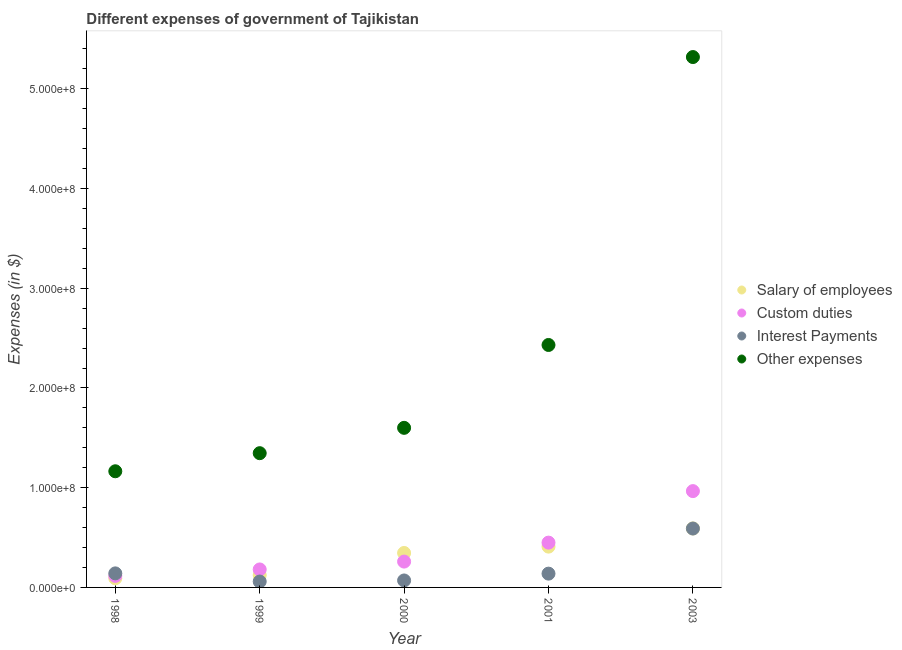Is the number of dotlines equal to the number of legend labels?
Your answer should be very brief. Yes. What is the amount spent on interest payments in 2001?
Keep it short and to the point. 1.38e+07. Across all years, what is the maximum amount spent on salary of employees?
Provide a succinct answer. 5.91e+07. Across all years, what is the minimum amount spent on interest payments?
Offer a very short reply. 5.92e+06. In which year was the amount spent on other expenses maximum?
Give a very brief answer. 2003. In which year was the amount spent on other expenses minimum?
Ensure brevity in your answer.  1998. What is the total amount spent on salary of employees in the graph?
Your response must be concise. 1.56e+08. What is the difference between the amount spent on other expenses in 1999 and that in 2001?
Provide a short and direct response. -1.08e+08. What is the difference between the amount spent on interest payments in 2000 and the amount spent on custom duties in 1998?
Keep it short and to the point. -4.60e+06. What is the average amount spent on custom duties per year?
Your response must be concise. 3.94e+07. In the year 2000, what is the difference between the amount spent on custom duties and amount spent on other expenses?
Ensure brevity in your answer.  -1.34e+08. What is the ratio of the amount spent on salary of employees in 1998 to that in 2001?
Your answer should be very brief. 0.22. Is the amount spent on salary of employees in 2000 less than that in 2001?
Your response must be concise. Yes. What is the difference between the highest and the second highest amount spent on salary of employees?
Offer a terse response. 1.82e+07. What is the difference between the highest and the lowest amount spent on interest payments?
Provide a succinct answer. 5.31e+07. In how many years, is the amount spent on salary of employees greater than the average amount spent on salary of employees taken over all years?
Keep it short and to the point. 3. Is it the case that in every year, the sum of the amount spent on custom duties and amount spent on other expenses is greater than the sum of amount spent on salary of employees and amount spent on interest payments?
Your response must be concise. No. Is it the case that in every year, the sum of the amount spent on salary of employees and amount spent on custom duties is greater than the amount spent on interest payments?
Provide a short and direct response. Yes. Does the amount spent on interest payments monotonically increase over the years?
Give a very brief answer. No. Is the amount spent on custom duties strictly greater than the amount spent on interest payments over the years?
Offer a very short reply. No. Is the amount spent on salary of employees strictly less than the amount spent on other expenses over the years?
Provide a short and direct response. Yes. How many dotlines are there?
Provide a succinct answer. 4. How many years are there in the graph?
Your answer should be compact. 5. What is the difference between two consecutive major ticks on the Y-axis?
Your answer should be compact. 1.00e+08. Are the values on the major ticks of Y-axis written in scientific E-notation?
Provide a succinct answer. Yes. Does the graph contain any zero values?
Keep it short and to the point. No. Does the graph contain grids?
Ensure brevity in your answer.  No. How many legend labels are there?
Offer a terse response. 4. How are the legend labels stacked?
Your answer should be very brief. Vertical. What is the title of the graph?
Provide a succinct answer. Different expenses of government of Tajikistan. Does "Periodicity assessment" appear as one of the legend labels in the graph?
Offer a very short reply. No. What is the label or title of the Y-axis?
Provide a succinct answer. Expenses (in $). What is the Expenses (in $) in Salary of employees in 1998?
Provide a short and direct response. 9.12e+06. What is the Expenses (in $) in Custom duties in 1998?
Give a very brief answer. 1.16e+07. What is the Expenses (in $) in Interest Payments in 1998?
Your answer should be compact. 1.41e+07. What is the Expenses (in $) of Other expenses in 1998?
Provide a short and direct response. 1.16e+08. What is the Expenses (in $) of Salary of employees in 1999?
Offer a terse response. 1.22e+07. What is the Expenses (in $) of Custom duties in 1999?
Provide a succinct answer. 1.80e+07. What is the Expenses (in $) in Interest Payments in 1999?
Your response must be concise. 5.92e+06. What is the Expenses (in $) of Other expenses in 1999?
Offer a terse response. 1.35e+08. What is the Expenses (in $) of Salary of employees in 2000?
Give a very brief answer. 3.45e+07. What is the Expenses (in $) in Custom duties in 2000?
Ensure brevity in your answer.  2.59e+07. What is the Expenses (in $) in Interest Payments in 2000?
Make the answer very short. 6.98e+06. What is the Expenses (in $) of Other expenses in 2000?
Make the answer very short. 1.60e+08. What is the Expenses (in $) of Salary of employees in 2001?
Offer a very short reply. 4.09e+07. What is the Expenses (in $) in Custom duties in 2001?
Provide a succinct answer. 4.49e+07. What is the Expenses (in $) in Interest Payments in 2001?
Ensure brevity in your answer.  1.38e+07. What is the Expenses (in $) in Other expenses in 2001?
Offer a terse response. 2.43e+08. What is the Expenses (in $) in Salary of employees in 2003?
Give a very brief answer. 5.91e+07. What is the Expenses (in $) in Custom duties in 2003?
Your answer should be compact. 9.66e+07. What is the Expenses (in $) in Interest Payments in 2003?
Provide a succinct answer. 5.90e+07. What is the Expenses (in $) in Other expenses in 2003?
Your response must be concise. 5.32e+08. Across all years, what is the maximum Expenses (in $) of Salary of employees?
Provide a succinct answer. 5.91e+07. Across all years, what is the maximum Expenses (in $) of Custom duties?
Your answer should be very brief. 9.66e+07. Across all years, what is the maximum Expenses (in $) of Interest Payments?
Ensure brevity in your answer.  5.90e+07. Across all years, what is the maximum Expenses (in $) in Other expenses?
Offer a terse response. 5.32e+08. Across all years, what is the minimum Expenses (in $) in Salary of employees?
Offer a terse response. 9.12e+06. Across all years, what is the minimum Expenses (in $) of Custom duties?
Offer a terse response. 1.16e+07. Across all years, what is the minimum Expenses (in $) in Interest Payments?
Your answer should be very brief. 5.92e+06. Across all years, what is the minimum Expenses (in $) of Other expenses?
Your response must be concise. 1.16e+08. What is the total Expenses (in $) of Salary of employees in the graph?
Your response must be concise. 1.56e+08. What is the total Expenses (in $) in Custom duties in the graph?
Offer a very short reply. 1.97e+08. What is the total Expenses (in $) in Interest Payments in the graph?
Give a very brief answer. 9.99e+07. What is the total Expenses (in $) in Other expenses in the graph?
Keep it short and to the point. 1.19e+09. What is the difference between the Expenses (in $) of Salary of employees in 1998 and that in 1999?
Make the answer very short. -3.11e+06. What is the difference between the Expenses (in $) of Custom duties in 1998 and that in 1999?
Offer a terse response. -6.44e+06. What is the difference between the Expenses (in $) of Interest Payments in 1998 and that in 1999?
Offer a very short reply. 8.17e+06. What is the difference between the Expenses (in $) in Other expenses in 1998 and that in 1999?
Give a very brief answer. -1.81e+07. What is the difference between the Expenses (in $) of Salary of employees in 1998 and that in 2000?
Provide a succinct answer. -2.54e+07. What is the difference between the Expenses (in $) in Custom duties in 1998 and that in 2000?
Offer a terse response. -1.43e+07. What is the difference between the Expenses (in $) of Interest Payments in 1998 and that in 2000?
Give a very brief answer. 7.10e+06. What is the difference between the Expenses (in $) of Other expenses in 1998 and that in 2000?
Offer a terse response. -4.35e+07. What is the difference between the Expenses (in $) in Salary of employees in 1998 and that in 2001?
Keep it short and to the point. -3.18e+07. What is the difference between the Expenses (in $) in Custom duties in 1998 and that in 2001?
Provide a short and direct response. -3.33e+07. What is the difference between the Expenses (in $) of Interest Payments in 1998 and that in 2001?
Make the answer very short. 2.66e+05. What is the difference between the Expenses (in $) in Other expenses in 1998 and that in 2001?
Provide a short and direct response. -1.27e+08. What is the difference between the Expenses (in $) of Salary of employees in 1998 and that in 2003?
Your answer should be compact. -5.00e+07. What is the difference between the Expenses (in $) of Custom duties in 1998 and that in 2003?
Your response must be concise. -8.50e+07. What is the difference between the Expenses (in $) in Interest Payments in 1998 and that in 2003?
Provide a succinct answer. -4.50e+07. What is the difference between the Expenses (in $) of Other expenses in 1998 and that in 2003?
Give a very brief answer. -4.15e+08. What is the difference between the Expenses (in $) of Salary of employees in 1999 and that in 2000?
Ensure brevity in your answer.  -2.23e+07. What is the difference between the Expenses (in $) of Custom duties in 1999 and that in 2000?
Ensure brevity in your answer.  -7.88e+06. What is the difference between the Expenses (in $) in Interest Payments in 1999 and that in 2000?
Provide a short and direct response. -1.06e+06. What is the difference between the Expenses (in $) of Other expenses in 1999 and that in 2000?
Offer a terse response. -2.54e+07. What is the difference between the Expenses (in $) of Salary of employees in 1999 and that in 2001?
Your response must be concise. -2.87e+07. What is the difference between the Expenses (in $) in Custom duties in 1999 and that in 2001?
Keep it short and to the point. -2.69e+07. What is the difference between the Expenses (in $) in Interest Payments in 1999 and that in 2001?
Give a very brief answer. -7.90e+06. What is the difference between the Expenses (in $) in Other expenses in 1999 and that in 2001?
Provide a short and direct response. -1.08e+08. What is the difference between the Expenses (in $) of Salary of employees in 1999 and that in 2003?
Your response must be concise. -4.69e+07. What is the difference between the Expenses (in $) of Custom duties in 1999 and that in 2003?
Offer a very short reply. -7.85e+07. What is the difference between the Expenses (in $) of Interest Payments in 1999 and that in 2003?
Your response must be concise. -5.31e+07. What is the difference between the Expenses (in $) in Other expenses in 1999 and that in 2003?
Ensure brevity in your answer.  -3.97e+08. What is the difference between the Expenses (in $) of Salary of employees in 2000 and that in 2001?
Offer a terse response. -6.37e+06. What is the difference between the Expenses (in $) in Custom duties in 2000 and that in 2001?
Your answer should be compact. -1.90e+07. What is the difference between the Expenses (in $) in Interest Payments in 2000 and that in 2001?
Ensure brevity in your answer.  -6.84e+06. What is the difference between the Expenses (in $) of Other expenses in 2000 and that in 2001?
Keep it short and to the point. -8.31e+07. What is the difference between the Expenses (in $) in Salary of employees in 2000 and that in 2003?
Give a very brief answer. -2.46e+07. What is the difference between the Expenses (in $) in Custom duties in 2000 and that in 2003?
Your response must be concise. -7.07e+07. What is the difference between the Expenses (in $) of Interest Payments in 2000 and that in 2003?
Make the answer very short. -5.21e+07. What is the difference between the Expenses (in $) in Other expenses in 2000 and that in 2003?
Your response must be concise. -3.72e+08. What is the difference between the Expenses (in $) in Salary of employees in 2001 and that in 2003?
Offer a very short reply. -1.82e+07. What is the difference between the Expenses (in $) of Custom duties in 2001 and that in 2003?
Your response must be concise. -5.16e+07. What is the difference between the Expenses (in $) of Interest Payments in 2001 and that in 2003?
Your answer should be very brief. -4.52e+07. What is the difference between the Expenses (in $) in Other expenses in 2001 and that in 2003?
Your answer should be compact. -2.89e+08. What is the difference between the Expenses (in $) of Salary of employees in 1998 and the Expenses (in $) of Custom duties in 1999?
Offer a terse response. -8.90e+06. What is the difference between the Expenses (in $) in Salary of employees in 1998 and the Expenses (in $) in Interest Payments in 1999?
Provide a succinct answer. 3.20e+06. What is the difference between the Expenses (in $) in Salary of employees in 1998 and the Expenses (in $) in Other expenses in 1999?
Your response must be concise. -1.25e+08. What is the difference between the Expenses (in $) in Custom duties in 1998 and the Expenses (in $) in Interest Payments in 1999?
Make the answer very short. 5.67e+06. What is the difference between the Expenses (in $) in Custom duties in 1998 and the Expenses (in $) in Other expenses in 1999?
Keep it short and to the point. -1.23e+08. What is the difference between the Expenses (in $) of Interest Payments in 1998 and the Expenses (in $) of Other expenses in 1999?
Offer a very short reply. -1.21e+08. What is the difference between the Expenses (in $) of Salary of employees in 1998 and the Expenses (in $) of Custom duties in 2000?
Your response must be concise. -1.68e+07. What is the difference between the Expenses (in $) in Salary of employees in 1998 and the Expenses (in $) in Interest Payments in 2000?
Provide a short and direct response. 2.14e+06. What is the difference between the Expenses (in $) in Salary of employees in 1998 and the Expenses (in $) in Other expenses in 2000?
Your answer should be compact. -1.51e+08. What is the difference between the Expenses (in $) of Custom duties in 1998 and the Expenses (in $) of Interest Payments in 2000?
Your answer should be very brief. 4.60e+06. What is the difference between the Expenses (in $) in Custom duties in 1998 and the Expenses (in $) in Other expenses in 2000?
Offer a very short reply. -1.48e+08. What is the difference between the Expenses (in $) in Interest Payments in 1998 and the Expenses (in $) in Other expenses in 2000?
Offer a very short reply. -1.46e+08. What is the difference between the Expenses (in $) in Salary of employees in 1998 and the Expenses (in $) in Custom duties in 2001?
Offer a very short reply. -3.58e+07. What is the difference between the Expenses (in $) in Salary of employees in 1998 and the Expenses (in $) in Interest Payments in 2001?
Provide a succinct answer. -4.70e+06. What is the difference between the Expenses (in $) in Salary of employees in 1998 and the Expenses (in $) in Other expenses in 2001?
Provide a succinct answer. -2.34e+08. What is the difference between the Expenses (in $) in Custom duties in 1998 and the Expenses (in $) in Interest Payments in 2001?
Ensure brevity in your answer.  -2.24e+06. What is the difference between the Expenses (in $) of Custom duties in 1998 and the Expenses (in $) of Other expenses in 2001?
Your answer should be compact. -2.32e+08. What is the difference between the Expenses (in $) of Interest Payments in 1998 and the Expenses (in $) of Other expenses in 2001?
Your response must be concise. -2.29e+08. What is the difference between the Expenses (in $) in Salary of employees in 1998 and the Expenses (in $) in Custom duties in 2003?
Ensure brevity in your answer.  -8.74e+07. What is the difference between the Expenses (in $) of Salary of employees in 1998 and the Expenses (in $) of Interest Payments in 2003?
Ensure brevity in your answer.  -4.99e+07. What is the difference between the Expenses (in $) of Salary of employees in 1998 and the Expenses (in $) of Other expenses in 2003?
Your answer should be compact. -5.23e+08. What is the difference between the Expenses (in $) in Custom duties in 1998 and the Expenses (in $) in Interest Payments in 2003?
Your response must be concise. -4.75e+07. What is the difference between the Expenses (in $) in Custom duties in 1998 and the Expenses (in $) in Other expenses in 2003?
Your answer should be compact. -5.20e+08. What is the difference between the Expenses (in $) in Interest Payments in 1998 and the Expenses (in $) in Other expenses in 2003?
Offer a very short reply. -5.18e+08. What is the difference between the Expenses (in $) in Salary of employees in 1999 and the Expenses (in $) in Custom duties in 2000?
Offer a terse response. -1.37e+07. What is the difference between the Expenses (in $) of Salary of employees in 1999 and the Expenses (in $) of Interest Payments in 2000?
Your answer should be very brief. 5.25e+06. What is the difference between the Expenses (in $) of Salary of employees in 1999 and the Expenses (in $) of Other expenses in 2000?
Ensure brevity in your answer.  -1.48e+08. What is the difference between the Expenses (in $) of Custom duties in 1999 and the Expenses (in $) of Interest Payments in 2000?
Give a very brief answer. 1.10e+07. What is the difference between the Expenses (in $) in Custom duties in 1999 and the Expenses (in $) in Other expenses in 2000?
Make the answer very short. -1.42e+08. What is the difference between the Expenses (in $) in Interest Payments in 1999 and the Expenses (in $) in Other expenses in 2000?
Make the answer very short. -1.54e+08. What is the difference between the Expenses (in $) in Salary of employees in 1999 and the Expenses (in $) in Custom duties in 2001?
Keep it short and to the point. -3.27e+07. What is the difference between the Expenses (in $) in Salary of employees in 1999 and the Expenses (in $) in Interest Payments in 2001?
Your response must be concise. -1.59e+06. What is the difference between the Expenses (in $) of Salary of employees in 1999 and the Expenses (in $) of Other expenses in 2001?
Your answer should be very brief. -2.31e+08. What is the difference between the Expenses (in $) of Custom duties in 1999 and the Expenses (in $) of Interest Payments in 2001?
Make the answer very short. 4.20e+06. What is the difference between the Expenses (in $) of Custom duties in 1999 and the Expenses (in $) of Other expenses in 2001?
Offer a terse response. -2.25e+08. What is the difference between the Expenses (in $) of Interest Payments in 1999 and the Expenses (in $) of Other expenses in 2001?
Offer a terse response. -2.37e+08. What is the difference between the Expenses (in $) of Salary of employees in 1999 and the Expenses (in $) of Custom duties in 2003?
Offer a terse response. -8.43e+07. What is the difference between the Expenses (in $) in Salary of employees in 1999 and the Expenses (in $) in Interest Payments in 2003?
Your answer should be compact. -4.68e+07. What is the difference between the Expenses (in $) in Salary of employees in 1999 and the Expenses (in $) in Other expenses in 2003?
Your answer should be compact. -5.20e+08. What is the difference between the Expenses (in $) in Custom duties in 1999 and the Expenses (in $) in Interest Payments in 2003?
Keep it short and to the point. -4.10e+07. What is the difference between the Expenses (in $) in Custom duties in 1999 and the Expenses (in $) in Other expenses in 2003?
Ensure brevity in your answer.  -5.14e+08. What is the difference between the Expenses (in $) in Interest Payments in 1999 and the Expenses (in $) in Other expenses in 2003?
Offer a terse response. -5.26e+08. What is the difference between the Expenses (in $) in Salary of employees in 2000 and the Expenses (in $) in Custom duties in 2001?
Give a very brief answer. -1.04e+07. What is the difference between the Expenses (in $) of Salary of employees in 2000 and the Expenses (in $) of Interest Payments in 2001?
Your answer should be compact. 2.07e+07. What is the difference between the Expenses (in $) of Salary of employees in 2000 and the Expenses (in $) of Other expenses in 2001?
Offer a very short reply. -2.09e+08. What is the difference between the Expenses (in $) of Custom duties in 2000 and the Expenses (in $) of Interest Payments in 2001?
Your answer should be very brief. 1.21e+07. What is the difference between the Expenses (in $) in Custom duties in 2000 and the Expenses (in $) in Other expenses in 2001?
Offer a very short reply. -2.17e+08. What is the difference between the Expenses (in $) in Interest Payments in 2000 and the Expenses (in $) in Other expenses in 2001?
Offer a very short reply. -2.36e+08. What is the difference between the Expenses (in $) of Salary of employees in 2000 and the Expenses (in $) of Custom duties in 2003?
Ensure brevity in your answer.  -6.20e+07. What is the difference between the Expenses (in $) in Salary of employees in 2000 and the Expenses (in $) in Interest Payments in 2003?
Keep it short and to the point. -2.45e+07. What is the difference between the Expenses (in $) in Salary of employees in 2000 and the Expenses (in $) in Other expenses in 2003?
Your answer should be very brief. -4.97e+08. What is the difference between the Expenses (in $) in Custom duties in 2000 and the Expenses (in $) in Interest Payments in 2003?
Provide a short and direct response. -3.31e+07. What is the difference between the Expenses (in $) of Custom duties in 2000 and the Expenses (in $) of Other expenses in 2003?
Your response must be concise. -5.06e+08. What is the difference between the Expenses (in $) in Interest Payments in 2000 and the Expenses (in $) in Other expenses in 2003?
Offer a very short reply. -5.25e+08. What is the difference between the Expenses (in $) of Salary of employees in 2001 and the Expenses (in $) of Custom duties in 2003?
Give a very brief answer. -5.57e+07. What is the difference between the Expenses (in $) in Salary of employees in 2001 and the Expenses (in $) in Interest Payments in 2003?
Provide a short and direct response. -1.81e+07. What is the difference between the Expenses (in $) of Salary of employees in 2001 and the Expenses (in $) of Other expenses in 2003?
Offer a very short reply. -4.91e+08. What is the difference between the Expenses (in $) in Custom duties in 2001 and the Expenses (in $) in Interest Payments in 2003?
Ensure brevity in your answer.  -1.41e+07. What is the difference between the Expenses (in $) of Custom duties in 2001 and the Expenses (in $) of Other expenses in 2003?
Give a very brief answer. -4.87e+08. What is the difference between the Expenses (in $) in Interest Payments in 2001 and the Expenses (in $) in Other expenses in 2003?
Your answer should be very brief. -5.18e+08. What is the average Expenses (in $) of Salary of employees per year?
Offer a very short reply. 3.12e+07. What is the average Expenses (in $) of Custom duties per year?
Keep it short and to the point. 3.94e+07. What is the average Expenses (in $) of Interest Payments per year?
Your answer should be very brief. 2.00e+07. What is the average Expenses (in $) in Other expenses per year?
Offer a very short reply. 2.37e+08. In the year 1998, what is the difference between the Expenses (in $) of Salary of employees and Expenses (in $) of Custom duties?
Ensure brevity in your answer.  -2.46e+06. In the year 1998, what is the difference between the Expenses (in $) of Salary of employees and Expenses (in $) of Interest Payments?
Keep it short and to the point. -4.96e+06. In the year 1998, what is the difference between the Expenses (in $) in Salary of employees and Expenses (in $) in Other expenses?
Provide a succinct answer. -1.07e+08. In the year 1998, what is the difference between the Expenses (in $) of Custom duties and Expenses (in $) of Interest Payments?
Ensure brevity in your answer.  -2.50e+06. In the year 1998, what is the difference between the Expenses (in $) in Custom duties and Expenses (in $) in Other expenses?
Your response must be concise. -1.05e+08. In the year 1998, what is the difference between the Expenses (in $) of Interest Payments and Expenses (in $) of Other expenses?
Your response must be concise. -1.02e+08. In the year 1999, what is the difference between the Expenses (in $) of Salary of employees and Expenses (in $) of Custom duties?
Your answer should be very brief. -5.79e+06. In the year 1999, what is the difference between the Expenses (in $) of Salary of employees and Expenses (in $) of Interest Payments?
Your answer should be very brief. 6.32e+06. In the year 1999, what is the difference between the Expenses (in $) of Salary of employees and Expenses (in $) of Other expenses?
Offer a terse response. -1.22e+08. In the year 1999, what is the difference between the Expenses (in $) of Custom duties and Expenses (in $) of Interest Payments?
Provide a succinct answer. 1.21e+07. In the year 1999, what is the difference between the Expenses (in $) of Custom duties and Expenses (in $) of Other expenses?
Your answer should be compact. -1.17e+08. In the year 1999, what is the difference between the Expenses (in $) in Interest Payments and Expenses (in $) in Other expenses?
Your response must be concise. -1.29e+08. In the year 2000, what is the difference between the Expenses (in $) in Salary of employees and Expenses (in $) in Custom duties?
Give a very brief answer. 8.64e+06. In the year 2000, what is the difference between the Expenses (in $) in Salary of employees and Expenses (in $) in Interest Payments?
Your answer should be very brief. 2.76e+07. In the year 2000, what is the difference between the Expenses (in $) in Salary of employees and Expenses (in $) in Other expenses?
Provide a succinct answer. -1.25e+08. In the year 2000, what is the difference between the Expenses (in $) of Custom duties and Expenses (in $) of Interest Payments?
Offer a very short reply. 1.89e+07. In the year 2000, what is the difference between the Expenses (in $) in Custom duties and Expenses (in $) in Other expenses?
Keep it short and to the point. -1.34e+08. In the year 2000, what is the difference between the Expenses (in $) of Interest Payments and Expenses (in $) of Other expenses?
Provide a succinct answer. -1.53e+08. In the year 2001, what is the difference between the Expenses (in $) of Salary of employees and Expenses (in $) of Custom duties?
Your answer should be compact. -4.02e+06. In the year 2001, what is the difference between the Expenses (in $) of Salary of employees and Expenses (in $) of Interest Payments?
Your answer should be very brief. 2.71e+07. In the year 2001, what is the difference between the Expenses (in $) of Salary of employees and Expenses (in $) of Other expenses?
Make the answer very short. -2.02e+08. In the year 2001, what is the difference between the Expenses (in $) of Custom duties and Expenses (in $) of Interest Payments?
Provide a succinct answer. 3.11e+07. In the year 2001, what is the difference between the Expenses (in $) in Custom duties and Expenses (in $) in Other expenses?
Offer a terse response. -1.98e+08. In the year 2001, what is the difference between the Expenses (in $) of Interest Payments and Expenses (in $) of Other expenses?
Offer a very short reply. -2.29e+08. In the year 2003, what is the difference between the Expenses (in $) of Salary of employees and Expenses (in $) of Custom duties?
Your answer should be very brief. -3.74e+07. In the year 2003, what is the difference between the Expenses (in $) in Salary of employees and Expenses (in $) in Interest Payments?
Offer a very short reply. 8.10e+04. In the year 2003, what is the difference between the Expenses (in $) in Salary of employees and Expenses (in $) in Other expenses?
Provide a succinct answer. -4.73e+08. In the year 2003, what is the difference between the Expenses (in $) of Custom duties and Expenses (in $) of Interest Payments?
Your answer should be compact. 3.75e+07. In the year 2003, what is the difference between the Expenses (in $) of Custom duties and Expenses (in $) of Other expenses?
Make the answer very short. -4.35e+08. In the year 2003, what is the difference between the Expenses (in $) of Interest Payments and Expenses (in $) of Other expenses?
Your answer should be very brief. -4.73e+08. What is the ratio of the Expenses (in $) of Salary of employees in 1998 to that in 1999?
Your response must be concise. 0.75. What is the ratio of the Expenses (in $) of Custom duties in 1998 to that in 1999?
Your answer should be very brief. 0.64. What is the ratio of the Expenses (in $) of Interest Payments in 1998 to that in 1999?
Offer a very short reply. 2.38. What is the ratio of the Expenses (in $) of Other expenses in 1998 to that in 1999?
Make the answer very short. 0.87. What is the ratio of the Expenses (in $) in Salary of employees in 1998 to that in 2000?
Your answer should be very brief. 0.26. What is the ratio of the Expenses (in $) in Custom duties in 1998 to that in 2000?
Keep it short and to the point. 0.45. What is the ratio of the Expenses (in $) of Interest Payments in 1998 to that in 2000?
Keep it short and to the point. 2.02. What is the ratio of the Expenses (in $) of Other expenses in 1998 to that in 2000?
Your response must be concise. 0.73. What is the ratio of the Expenses (in $) in Salary of employees in 1998 to that in 2001?
Your answer should be compact. 0.22. What is the ratio of the Expenses (in $) in Custom duties in 1998 to that in 2001?
Provide a short and direct response. 0.26. What is the ratio of the Expenses (in $) of Interest Payments in 1998 to that in 2001?
Offer a very short reply. 1.02. What is the ratio of the Expenses (in $) in Other expenses in 1998 to that in 2001?
Your response must be concise. 0.48. What is the ratio of the Expenses (in $) in Salary of employees in 1998 to that in 2003?
Your answer should be compact. 0.15. What is the ratio of the Expenses (in $) in Custom duties in 1998 to that in 2003?
Ensure brevity in your answer.  0.12. What is the ratio of the Expenses (in $) in Interest Payments in 1998 to that in 2003?
Provide a succinct answer. 0.24. What is the ratio of the Expenses (in $) in Other expenses in 1998 to that in 2003?
Your answer should be very brief. 0.22. What is the ratio of the Expenses (in $) in Salary of employees in 1999 to that in 2000?
Give a very brief answer. 0.35. What is the ratio of the Expenses (in $) in Custom duties in 1999 to that in 2000?
Give a very brief answer. 0.7. What is the ratio of the Expenses (in $) in Interest Payments in 1999 to that in 2000?
Provide a short and direct response. 0.85. What is the ratio of the Expenses (in $) in Other expenses in 1999 to that in 2000?
Provide a succinct answer. 0.84. What is the ratio of the Expenses (in $) in Salary of employees in 1999 to that in 2001?
Offer a very short reply. 0.3. What is the ratio of the Expenses (in $) in Custom duties in 1999 to that in 2001?
Provide a short and direct response. 0.4. What is the ratio of the Expenses (in $) of Interest Payments in 1999 to that in 2001?
Provide a succinct answer. 0.43. What is the ratio of the Expenses (in $) of Other expenses in 1999 to that in 2001?
Offer a very short reply. 0.55. What is the ratio of the Expenses (in $) in Salary of employees in 1999 to that in 2003?
Provide a succinct answer. 0.21. What is the ratio of the Expenses (in $) of Custom duties in 1999 to that in 2003?
Offer a terse response. 0.19. What is the ratio of the Expenses (in $) of Interest Payments in 1999 to that in 2003?
Offer a terse response. 0.1. What is the ratio of the Expenses (in $) of Other expenses in 1999 to that in 2003?
Offer a terse response. 0.25. What is the ratio of the Expenses (in $) of Salary of employees in 2000 to that in 2001?
Provide a succinct answer. 0.84. What is the ratio of the Expenses (in $) of Custom duties in 2000 to that in 2001?
Provide a short and direct response. 0.58. What is the ratio of the Expenses (in $) in Interest Payments in 2000 to that in 2001?
Ensure brevity in your answer.  0.51. What is the ratio of the Expenses (in $) in Other expenses in 2000 to that in 2001?
Offer a very short reply. 0.66. What is the ratio of the Expenses (in $) of Salary of employees in 2000 to that in 2003?
Your answer should be compact. 0.58. What is the ratio of the Expenses (in $) of Custom duties in 2000 to that in 2003?
Provide a short and direct response. 0.27. What is the ratio of the Expenses (in $) in Interest Payments in 2000 to that in 2003?
Provide a short and direct response. 0.12. What is the ratio of the Expenses (in $) in Other expenses in 2000 to that in 2003?
Give a very brief answer. 0.3. What is the ratio of the Expenses (in $) in Salary of employees in 2001 to that in 2003?
Offer a terse response. 0.69. What is the ratio of the Expenses (in $) of Custom duties in 2001 to that in 2003?
Offer a very short reply. 0.47. What is the ratio of the Expenses (in $) of Interest Payments in 2001 to that in 2003?
Offer a very short reply. 0.23. What is the ratio of the Expenses (in $) in Other expenses in 2001 to that in 2003?
Your response must be concise. 0.46. What is the difference between the highest and the second highest Expenses (in $) of Salary of employees?
Your answer should be very brief. 1.82e+07. What is the difference between the highest and the second highest Expenses (in $) in Custom duties?
Give a very brief answer. 5.16e+07. What is the difference between the highest and the second highest Expenses (in $) in Interest Payments?
Your answer should be very brief. 4.50e+07. What is the difference between the highest and the second highest Expenses (in $) in Other expenses?
Keep it short and to the point. 2.89e+08. What is the difference between the highest and the lowest Expenses (in $) in Salary of employees?
Ensure brevity in your answer.  5.00e+07. What is the difference between the highest and the lowest Expenses (in $) of Custom duties?
Offer a terse response. 8.50e+07. What is the difference between the highest and the lowest Expenses (in $) in Interest Payments?
Provide a short and direct response. 5.31e+07. What is the difference between the highest and the lowest Expenses (in $) in Other expenses?
Offer a terse response. 4.15e+08. 